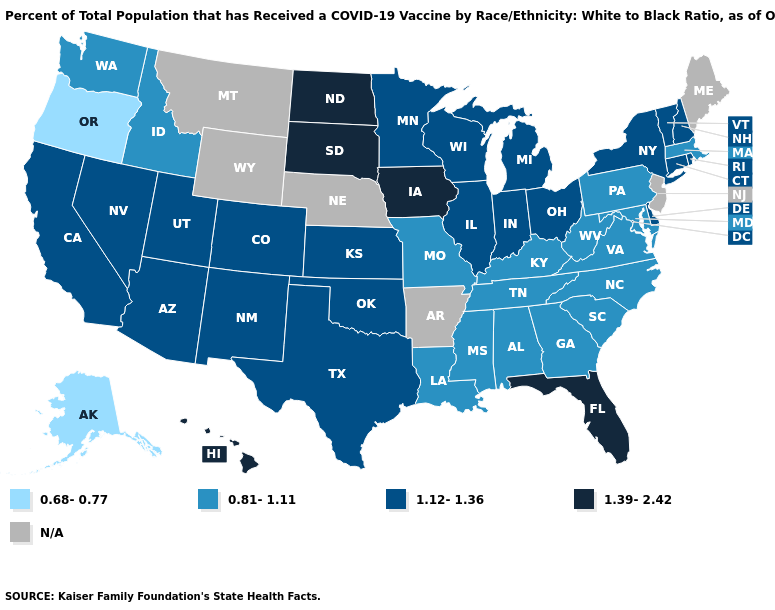Which states have the lowest value in the USA?
Write a very short answer. Alaska, Oregon. What is the value of Washington?
Answer briefly. 0.81-1.11. What is the value of Florida?
Short answer required. 1.39-2.42. What is the value of Idaho?
Quick response, please. 0.81-1.11. What is the lowest value in states that border Massachusetts?
Quick response, please. 1.12-1.36. Name the states that have a value in the range N/A?
Be succinct. Arkansas, Maine, Montana, Nebraska, New Jersey, Wyoming. Name the states that have a value in the range 0.68-0.77?
Short answer required. Alaska, Oregon. Name the states that have a value in the range 1.12-1.36?
Write a very short answer. Arizona, California, Colorado, Connecticut, Delaware, Illinois, Indiana, Kansas, Michigan, Minnesota, Nevada, New Hampshire, New Mexico, New York, Ohio, Oklahoma, Rhode Island, Texas, Utah, Vermont, Wisconsin. What is the highest value in the South ?
Give a very brief answer. 1.39-2.42. Which states have the lowest value in the South?
Keep it brief. Alabama, Georgia, Kentucky, Louisiana, Maryland, Mississippi, North Carolina, South Carolina, Tennessee, Virginia, West Virginia. Name the states that have a value in the range N/A?
Short answer required. Arkansas, Maine, Montana, Nebraska, New Jersey, Wyoming. How many symbols are there in the legend?
Concise answer only. 5. What is the value of Texas?
Keep it brief. 1.12-1.36. 